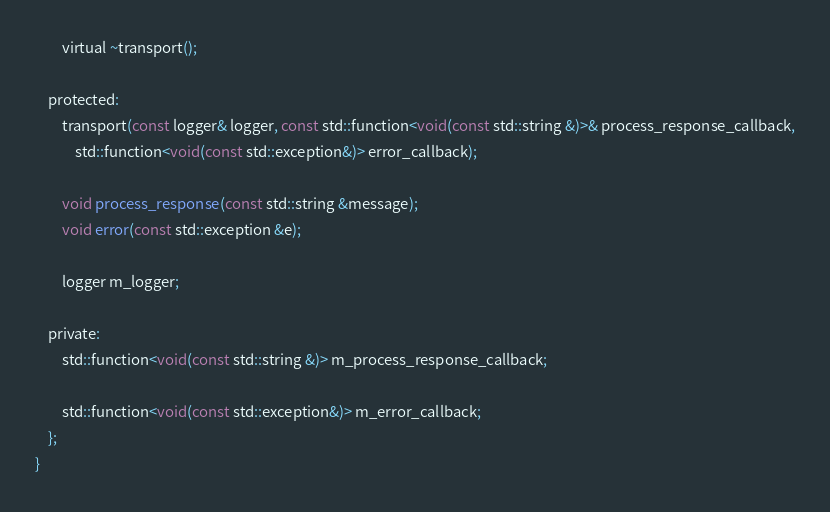<code> <loc_0><loc_0><loc_500><loc_500><_C_>
        virtual ~transport();

    protected:
        transport(const logger& logger, const std::function<void(const std::string &)>& process_response_callback,
            std::function<void(const std::exception&)> error_callback);

        void process_response(const std::string &message);
        void error(const std::exception &e);

        logger m_logger;

    private:
        std::function<void(const std::string &)> m_process_response_callback;

        std::function<void(const std::exception&)> m_error_callback;
    };
}
</code> 